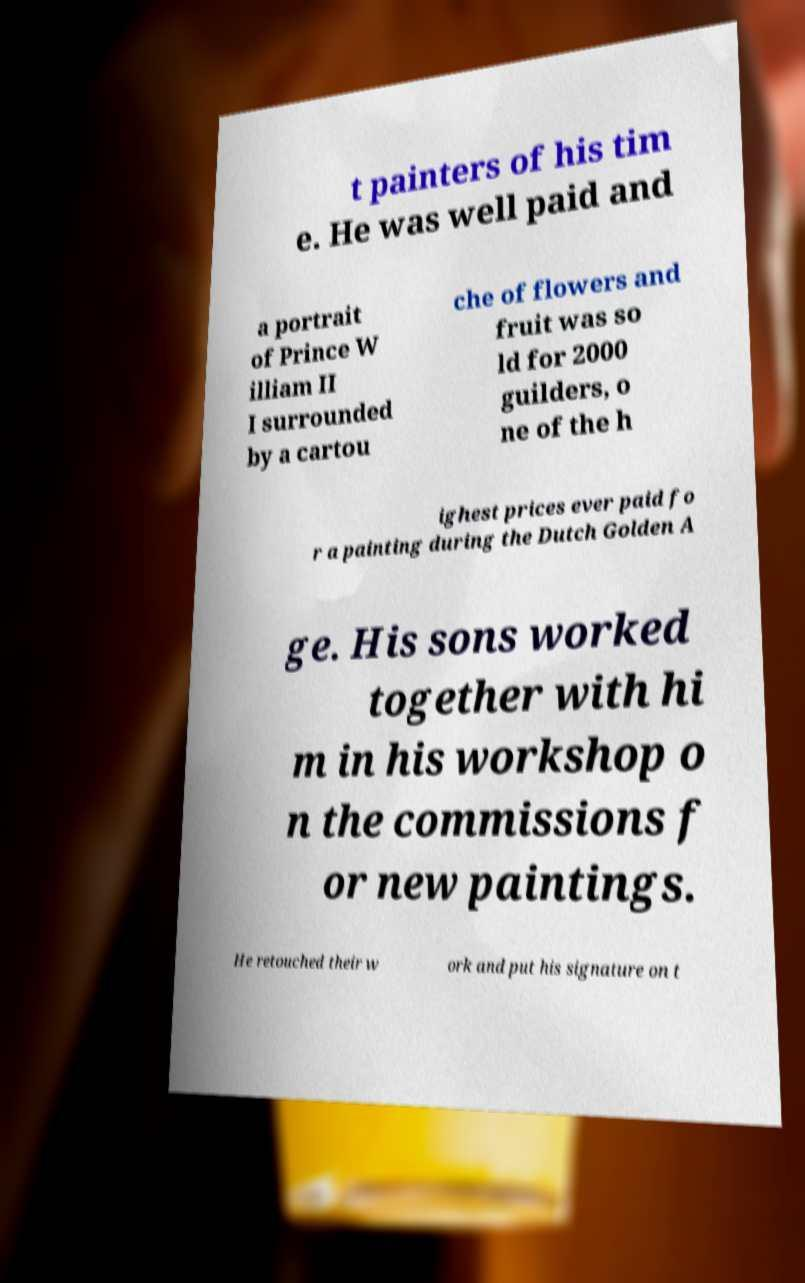There's text embedded in this image that I need extracted. Can you transcribe it verbatim? t painters of his tim e. He was well paid and a portrait of Prince W illiam II I surrounded by a cartou che of flowers and fruit was so ld for 2000 guilders, o ne of the h ighest prices ever paid fo r a painting during the Dutch Golden A ge. His sons worked together with hi m in his workshop o n the commissions f or new paintings. He retouched their w ork and put his signature on t 